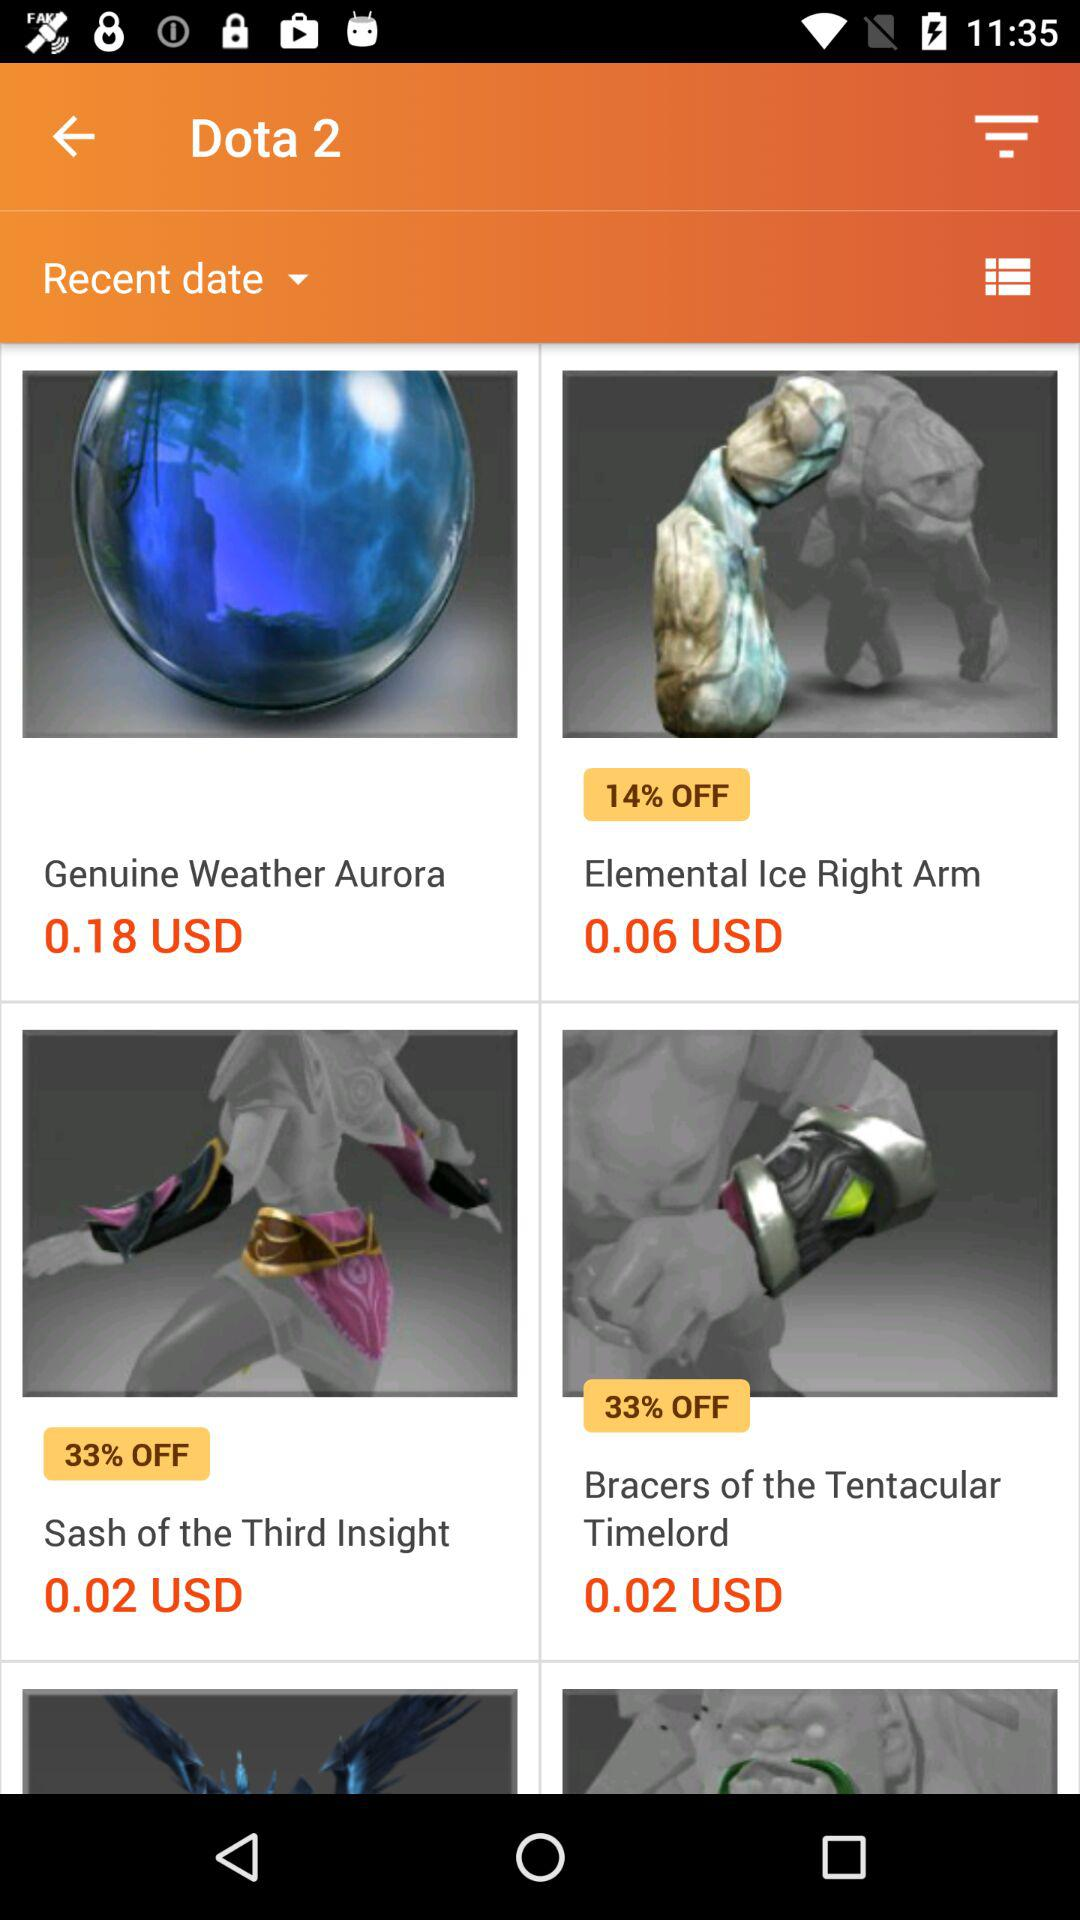How many items have a discount greater than 30%?
Answer the question using a single word or phrase. 2 